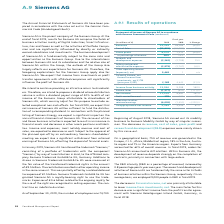According to Siemens Ag's financial document, What is the revenue break up based on geography? Based on the financial document, the answer is On a geographical basis, 75 % of revenue was generated in the Europe, C. I. S., Africa, Middle East region, 18 % in the Asia, Australia region and 7 % in the Americas region.. Also, What caused the decrease in revenue, cost of sales, gross profit and research and development (R&D) expenses? The decreases in revenue, cost of sales, gross profit and research and development (R & D) expenses were mainly driven by this carve-out.. The document states: "ens Mobility GmbH by way of singular succes- sion. The decreases in revenue, cost of sales, gross profit and research and development (R & D) expenses..." Also, On an average how many people are employed in R&D in fiscal in 2019? According to the financial document, 9,000. The relevant text states: "p, respectively. On an average basis, we employed 9,000 people in R & D in fiscal 2019...." Also, can you calculate: What is the average revenue for 2019 and 2018? To answer this question, I need to perform calculations using the financial data. The calculation is: (22,104 + 28,185) / 2, which equals 25144.5 (in millions). This is based on the information: "Revenue 22,104 28,185 (22) % Revenue 22,104 28,185 (22) %..." The key data points involved are: 22,104, 28,185. Also, can you calculate: What is the gross profit margin in 2019? Based on the calculation: 6,279 / 22,104, the result is 28.41 (percentage). This is based on the information: "Gross profit 6,279 7,111 (12) % Revenue 22,104 28,185 (22) %..." The key data points involved are: 22,104, 6,279. Also, can you calculate: What is the increase / (decrease) in Net Income from 2018 to 2019? Based on the calculation: 11,219 - 4,547, the result is 6672 (in millions). This is based on the information: "Net income 11,219 4,547 147 % Net income 11,219 4,547 147 %..." The key data points involved are: 11,219, 4,547. 